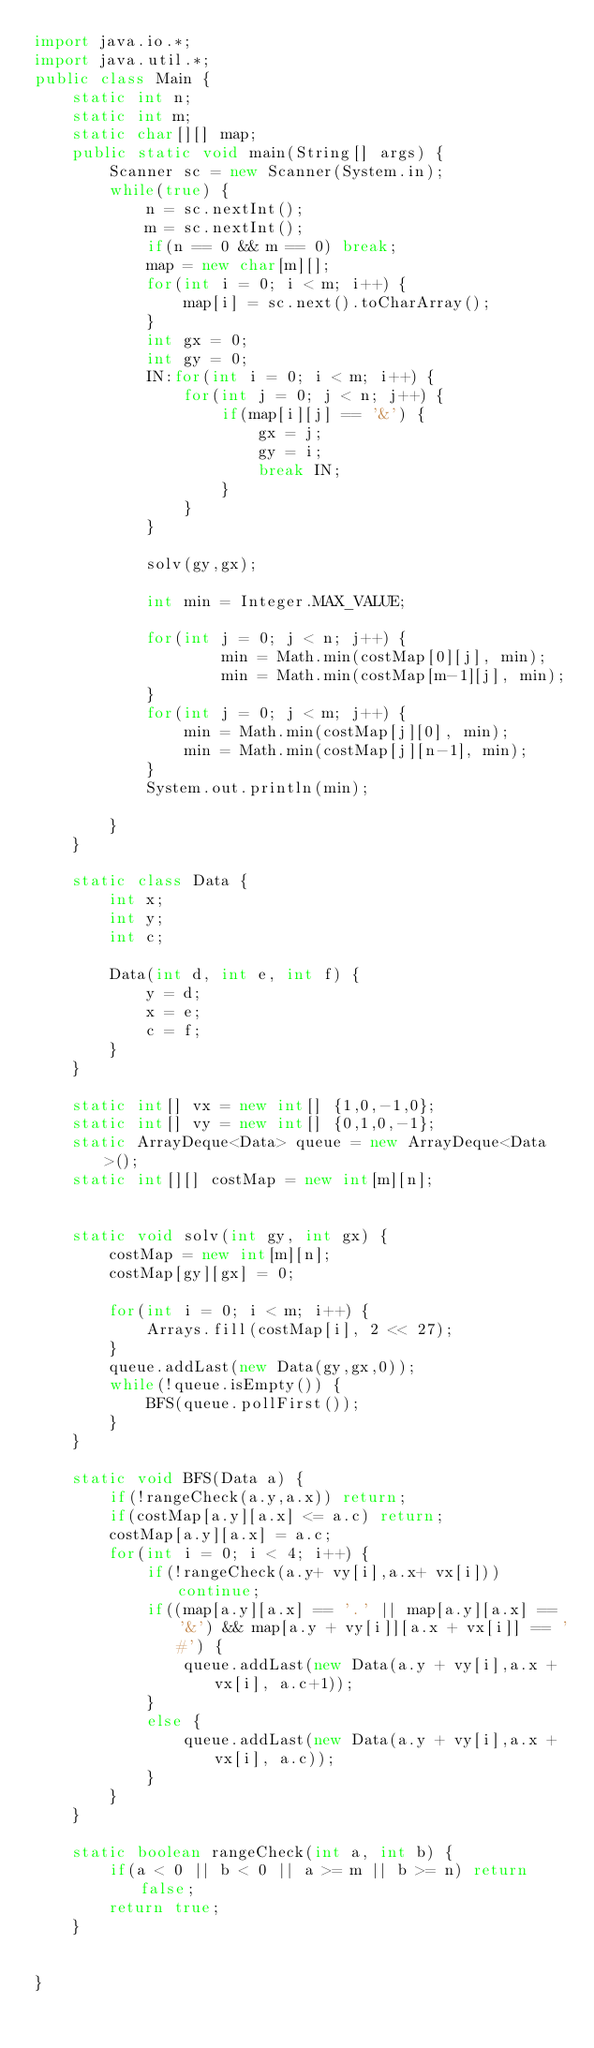Convert code to text. <code><loc_0><loc_0><loc_500><loc_500><_Java_>import java.io.*;
import java.util.*;
public class Main {
	static int n;
	static int m;
	static char[][] map;
	public static void main(String[] args) {
		Scanner sc = new Scanner(System.in);
		while(true) {
			n = sc.nextInt();
			m = sc.nextInt();
			if(n == 0 && m == 0) break;
			map = new char[m][];
			for(int i = 0; i < m; i++) {
				map[i] = sc.next().toCharArray();
			}
			int gx = 0;
			int gy = 0;
			IN:for(int i = 0; i < m; i++) {
				for(int j = 0; j < n; j++) {
					if(map[i][j] == '&') {
						gx = j;
						gy = i;
						break IN;
					}
				}
			}
			
			solv(gy,gx);
			
			int min = Integer.MAX_VALUE;
			
			for(int j = 0; j < n; j++) {
					min = Math.min(costMap[0][j], min);
					min = Math.min(costMap[m-1][j], min);
			}
			for(int j = 0; j < m; j++) {
				min = Math.min(costMap[j][0], min);
				min = Math.min(costMap[j][n-1], min);
			}
			System.out.println(min);
			
		}
	}
	
	static class Data {
		int x;
		int y;
		int c;
		
		Data(int d, int e, int f) {
			y = d;
			x = e;
			c = f;
		}
	}
	
	static int[] vx = new int[] {1,0,-1,0};
	static int[] vy = new int[] {0,1,0,-1};
	static ArrayDeque<Data> queue = new ArrayDeque<Data>();
	static int[][] costMap = new int[m][n];
	
	
	static void solv(int gy, int gx) {
		costMap = new int[m][n];
		costMap[gy][gx] = 0;
		
		for(int i = 0; i < m; i++) {
			Arrays.fill(costMap[i], 2 << 27);
		}
		queue.addLast(new Data(gy,gx,0));
		while(!queue.isEmpty()) {
			BFS(queue.pollFirst());
		}
	}
	
	static void BFS(Data a) {
		if(!rangeCheck(a.y,a.x)) return;
		if(costMap[a.y][a.x] <= a.c) return;
		costMap[a.y][a.x] = a.c;
		for(int i = 0; i < 4; i++) {
			if(!rangeCheck(a.y+ vy[i],a.x+ vx[i])) continue;
			if((map[a.y][a.x] == '.' || map[a.y][a.x] == '&') && map[a.y + vy[i]][a.x + vx[i]] == '#') {
				queue.addLast(new Data(a.y + vy[i],a.x + vx[i], a.c+1));
			}
			else {
				queue.addLast(new Data(a.y + vy[i],a.x + vx[i], a.c));
			}
		}
	}
	
	static boolean rangeCheck(int a, int b) {
		if(a < 0 || b < 0 || a >= m || b >= n) return false;
		return true;
	}
	
		
}</code> 